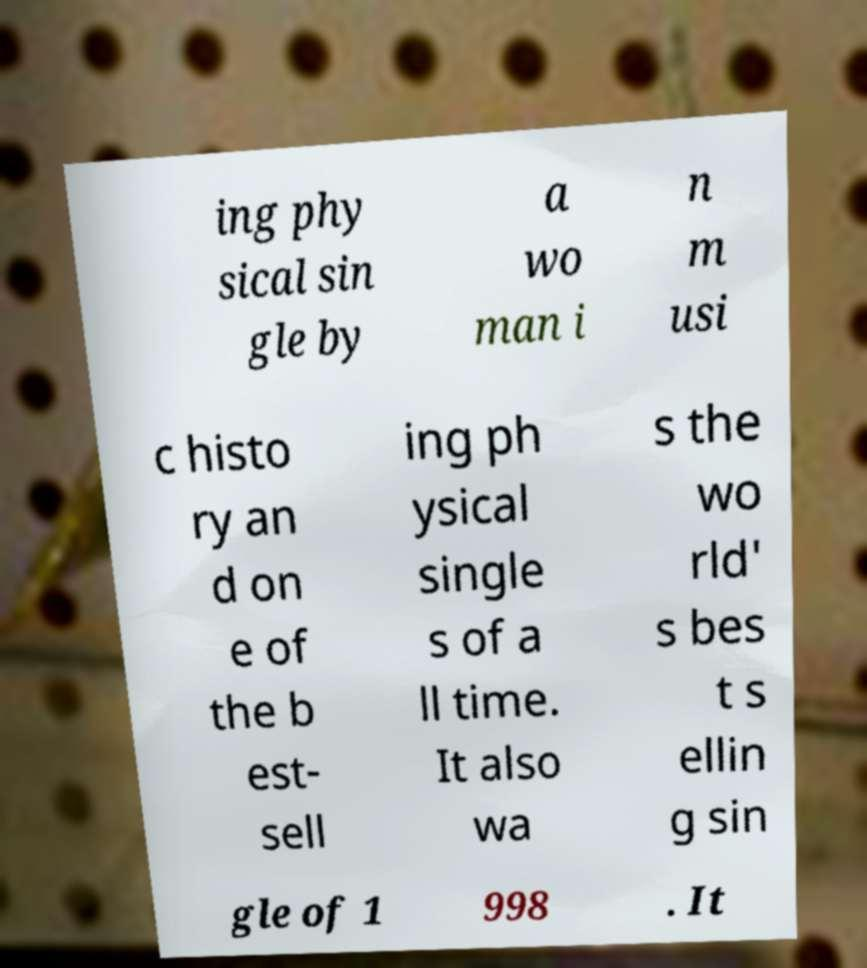Could you extract and type out the text from this image? ing phy sical sin gle by a wo man i n m usi c histo ry an d on e of the b est- sell ing ph ysical single s of a ll time. It also wa s the wo rld' s bes t s ellin g sin gle of 1 998 . It 